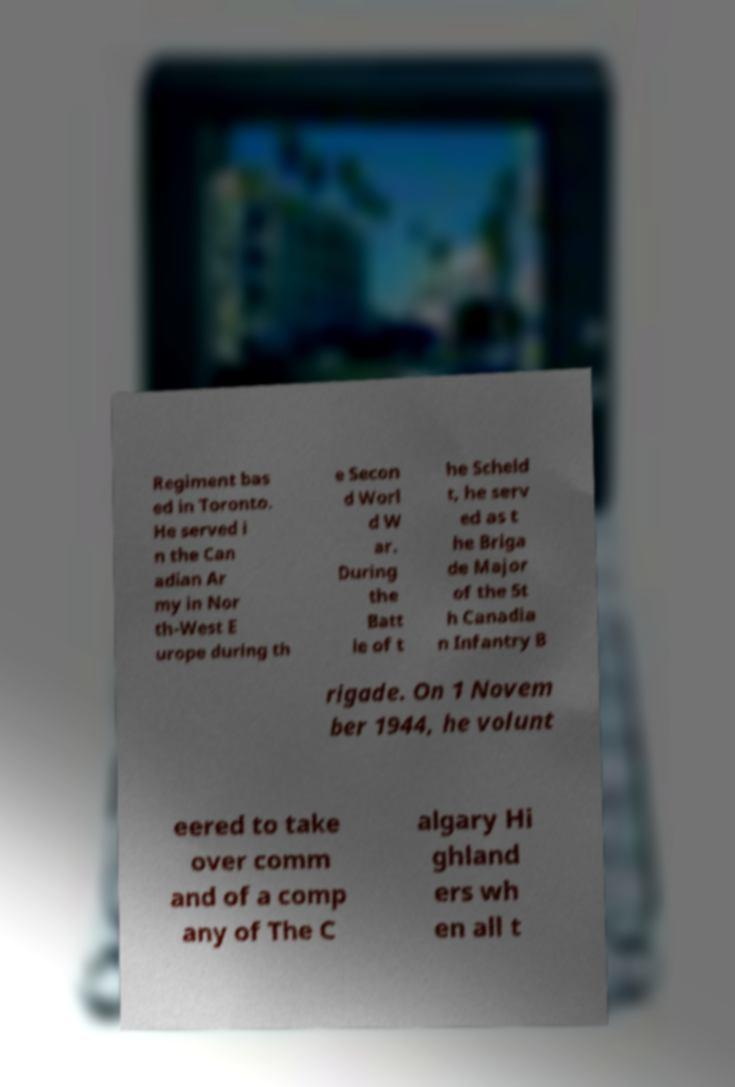There's text embedded in this image that I need extracted. Can you transcribe it verbatim? Regiment bas ed in Toronto. He served i n the Can adian Ar my in Nor th-West E urope during th e Secon d Worl d W ar. During the Batt le of t he Scheld t, he serv ed as t he Briga de Major of the 5t h Canadia n Infantry B rigade. On 1 Novem ber 1944, he volunt eered to take over comm and of a comp any of The C algary Hi ghland ers wh en all t 